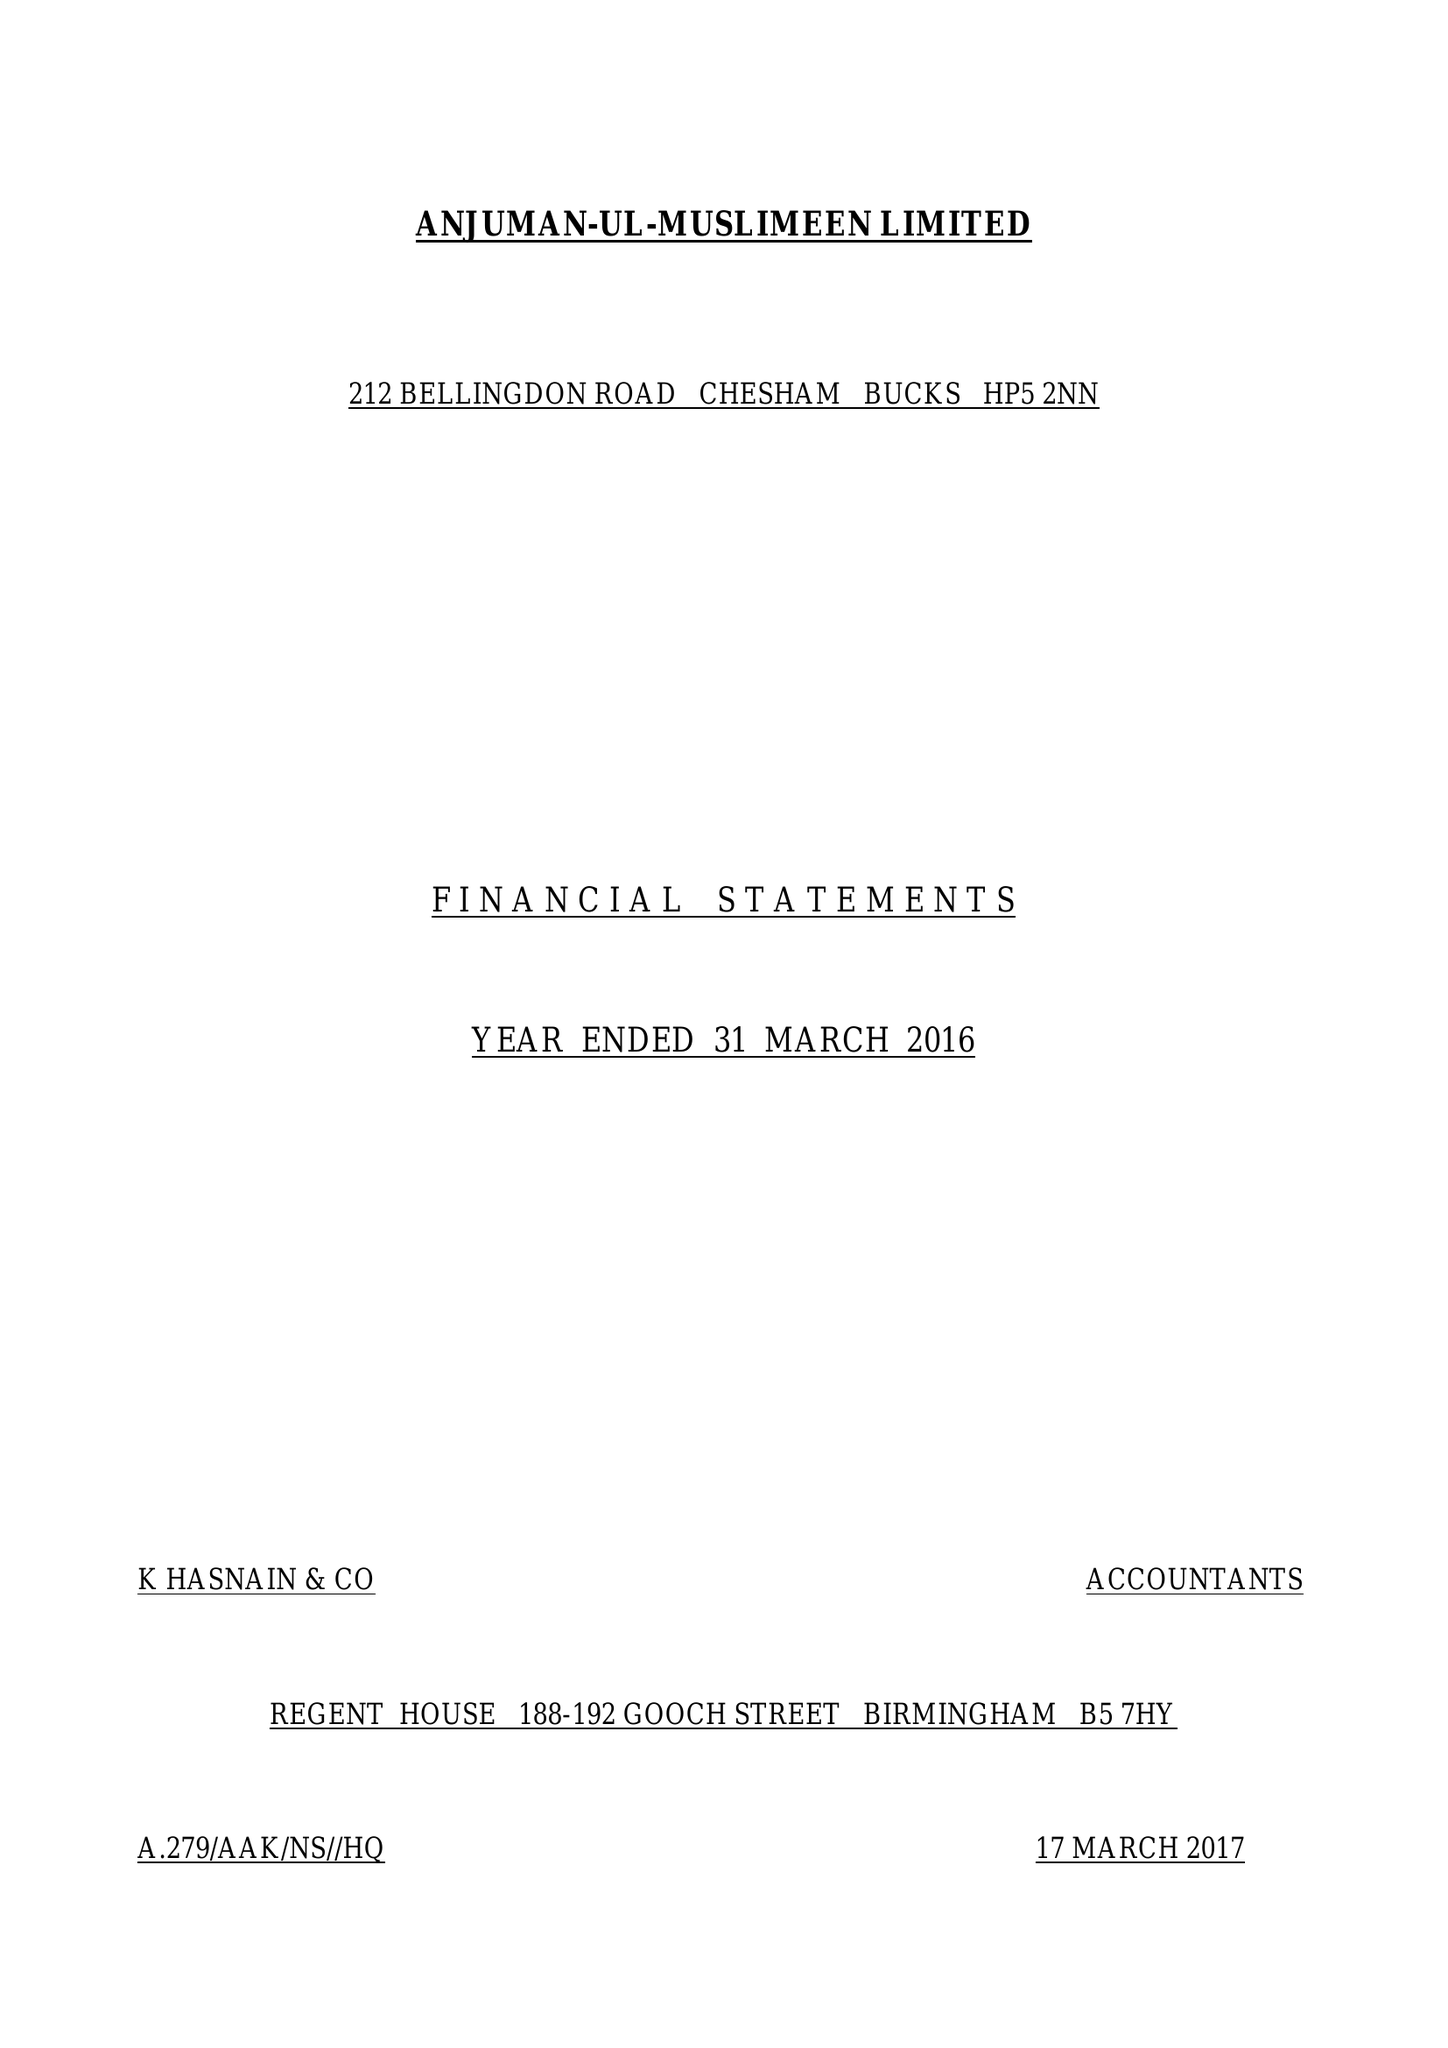What is the value for the address__postcode?
Answer the question using a single word or phrase. HP5 3AU 